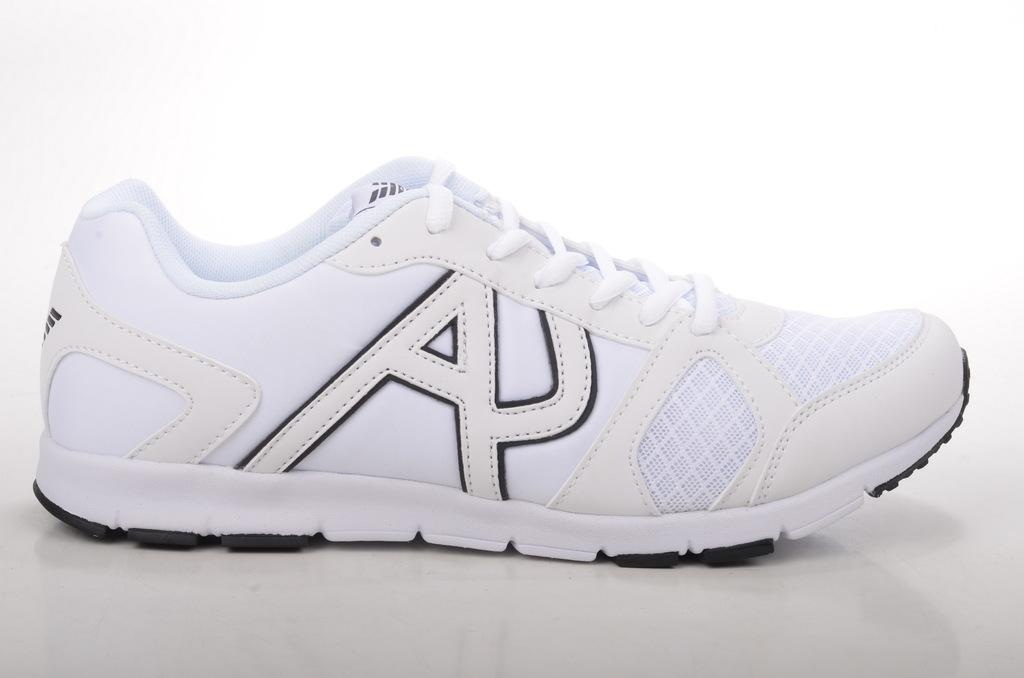What type of footwear is visible in the image? There is a white color shoe in the image. Where is the shoe placed in the image? The shoe is placed on a whiteboard. What type of cloud can be seen in the image? There are no clouds present in the image; it features a white color shoe placed on a whiteboard. What kind of van is parked next to the shoe in the image? There is no van present in the image; it only shows a white color shoe placed on a whiteboard. 